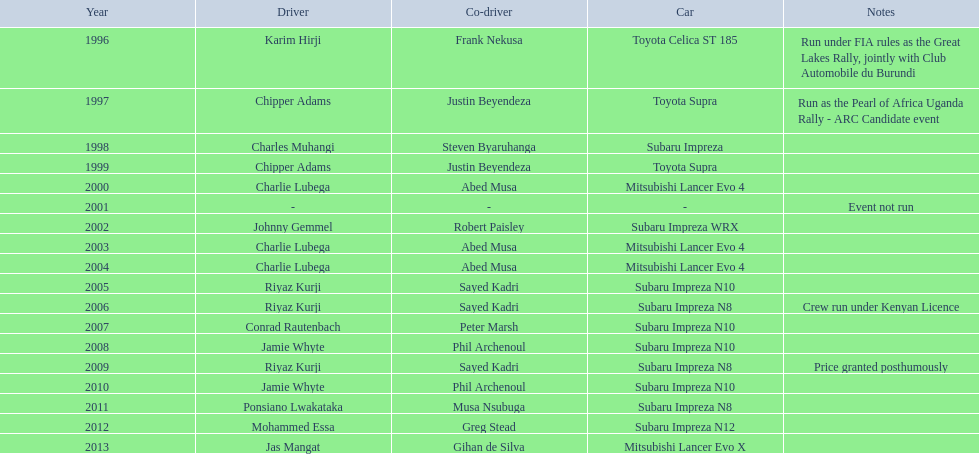Can you tell me the combined wins of chipper adams and justin beyendeza? 2. 